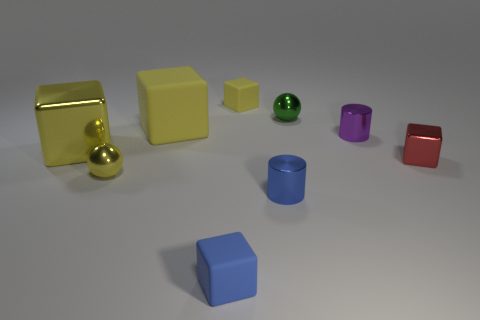What number of tiny balls are right of the shiny sphere that is in front of the large metallic object?
Offer a terse response. 1. Is there any other thing that is made of the same material as the red object?
Your response must be concise. Yes. What number of things are either tiny shiny things that are in front of the small purple metal cylinder or big cyan balls?
Keep it short and to the point. 3. How big is the yellow rubber thing in front of the tiny yellow rubber thing?
Make the answer very short. Large. What is the red block made of?
Provide a succinct answer. Metal. What shape is the green metallic thing behind the tiny ball that is on the left side of the small blue cylinder?
Provide a succinct answer. Sphere. What number of other objects are there of the same shape as the big yellow metallic object?
Your response must be concise. 4. There is a small purple metallic cylinder; are there any tiny rubber blocks on the right side of it?
Make the answer very short. No. What is the color of the tiny shiny block?
Your response must be concise. Red. There is a big metallic block; is its color the same as the ball that is right of the tiny blue matte thing?
Offer a terse response. No. 